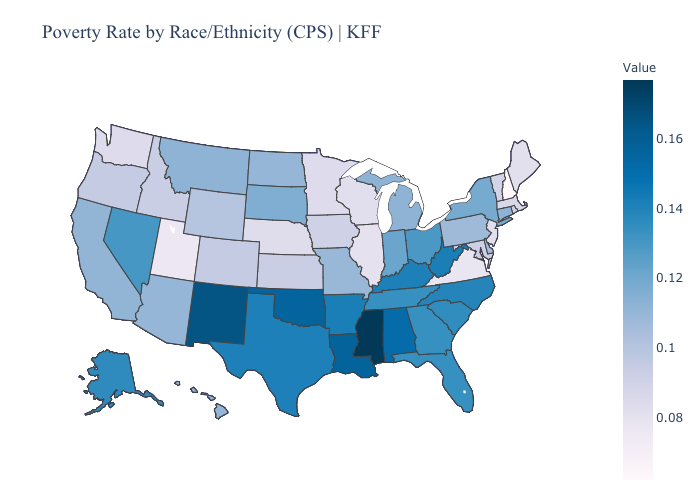Does Hawaii have a higher value than Arkansas?
Quick response, please. No. Does Texas have the highest value in the USA?
Be succinct. No. Does Mississippi have the highest value in the USA?
Answer briefly. Yes. Which states have the lowest value in the Northeast?
Short answer required. New Hampshire. Among the states that border Maryland , does Virginia have the lowest value?
Give a very brief answer. Yes. Which states hav the highest value in the MidWest?
Quick response, please. Ohio. Does New York have the highest value in the Northeast?
Short answer required. Yes. 